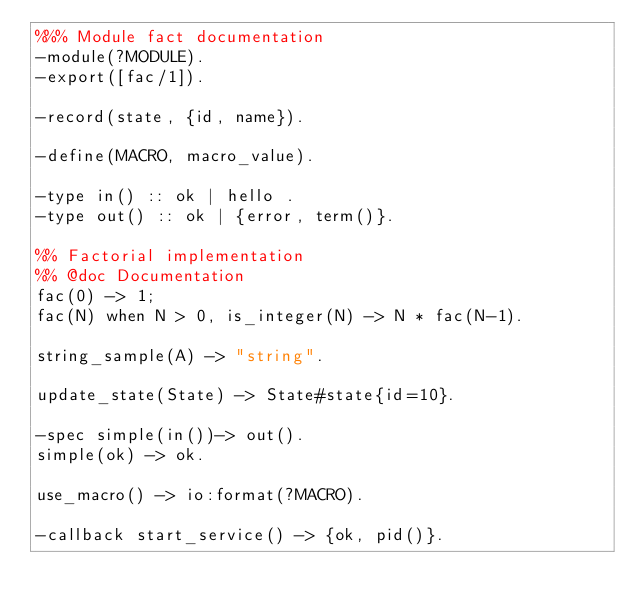Convert code to text. <code><loc_0><loc_0><loc_500><loc_500><_Erlang_>%%% Module fact documentation
-module(?MODULE).
-export([fac/1]).

-record(state, {id, name}).

-define(MACRO, macro_value).

-type in() :: ok | hello .
-type out() :: ok | {error, term()}.

%% Factorial implementation
%% @doc Documentation
fac(0) -> 1;
fac(N) when N > 0, is_integer(N) -> N * fac(N-1).

string_sample(A) -> "string".

update_state(State) -> State#state{id=10}.

-spec simple(in())-> out().
simple(ok) -> ok.

use_macro() -> io:format(?MACRO).

-callback start_service() -> {ok, pid()}.</code> 